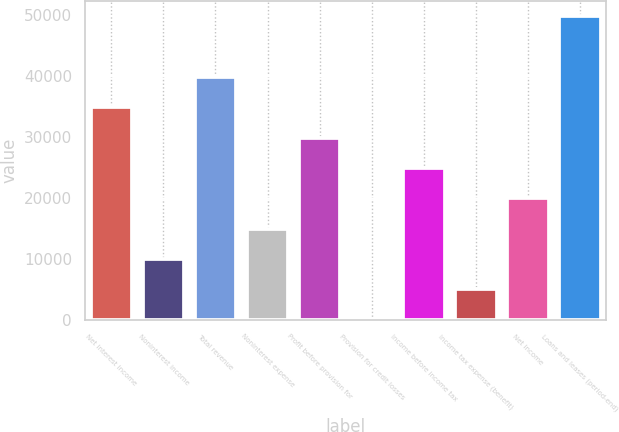Convert chart to OTSL. <chart><loc_0><loc_0><loc_500><loc_500><bar_chart><fcel>Net interest income<fcel>Noninterest income<fcel>Total revenue<fcel>Noninterest expense<fcel>Profit before provision for<fcel>Provision for credit losses<fcel>Income before income tax<fcel>Income tax expense (benefit)<fcel>Net income<fcel>Loans and leases (period-end)<nl><fcel>34828.6<fcel>9964.6<fcel>39801.4<fcel>14937.4<fcel>29855.8<fcel>19<fcel>24883<fcel>4991.8<fcel>19910.2<fcel>49747<nl></chart> 